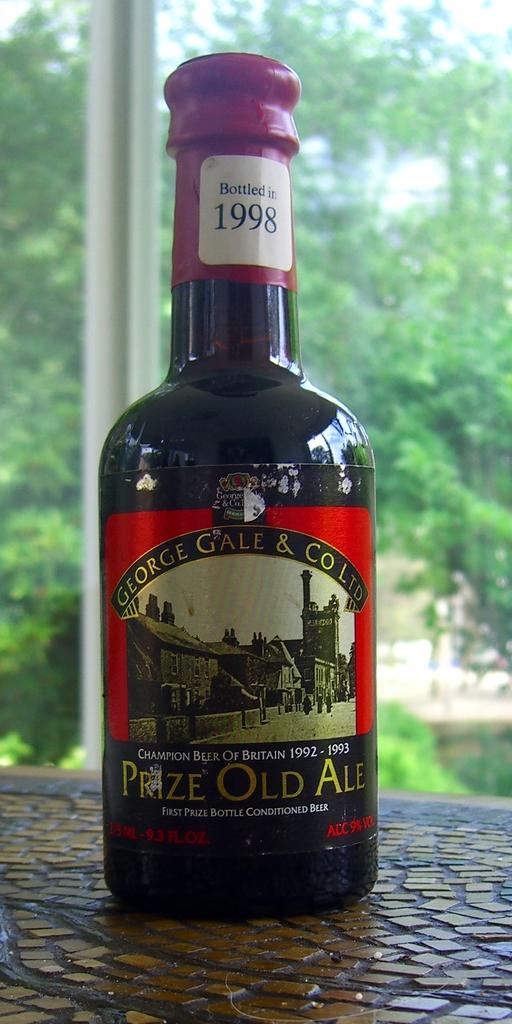What type of beer is this?
Give a very brief answer. Prize old ale. Is that an english beer?
Your answer should be compact. Yes. 